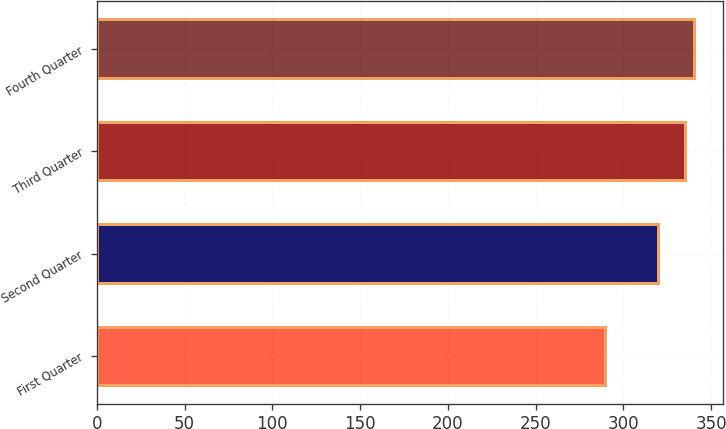<chart> <loc_0><loc_0><loc_500><loc_500><bar_chart><fcel>First Quarter<fcel>Second Quarter<fcel>Third Quarter<fcel>Fourth Quarter<nl><fcel>289.72<fcel>319.54<fcel>335.11<fcel>340<nl></chart> 